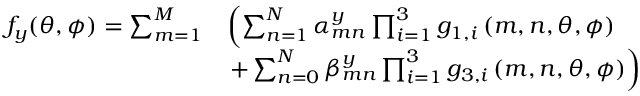<formula> <loc_0><loc_0><loc_500><loc_500>\begin{array} { r l } { f _ { y } ( \theta , \phi ) = \sum _ { m = 1 } ^ { M } } & { \left ( \sum _ { n = 1 } ^ { N } \alpha _ { m n } ^ { y } \prod _ { i = 1 } ^ { 3 } { g _ { 1 , i } } \left ( m , n , \theta , \phi \right ) } \\ & { + \sum _ { n = 0 } ^ { N } \beta _ { m n } ^ { y } \prod _ { i = 1 } ^ { 3 } { g _ { 3 , i } } \left ( m , n , \theta , \phi \right ) \right ) } \end{array}</formula> 